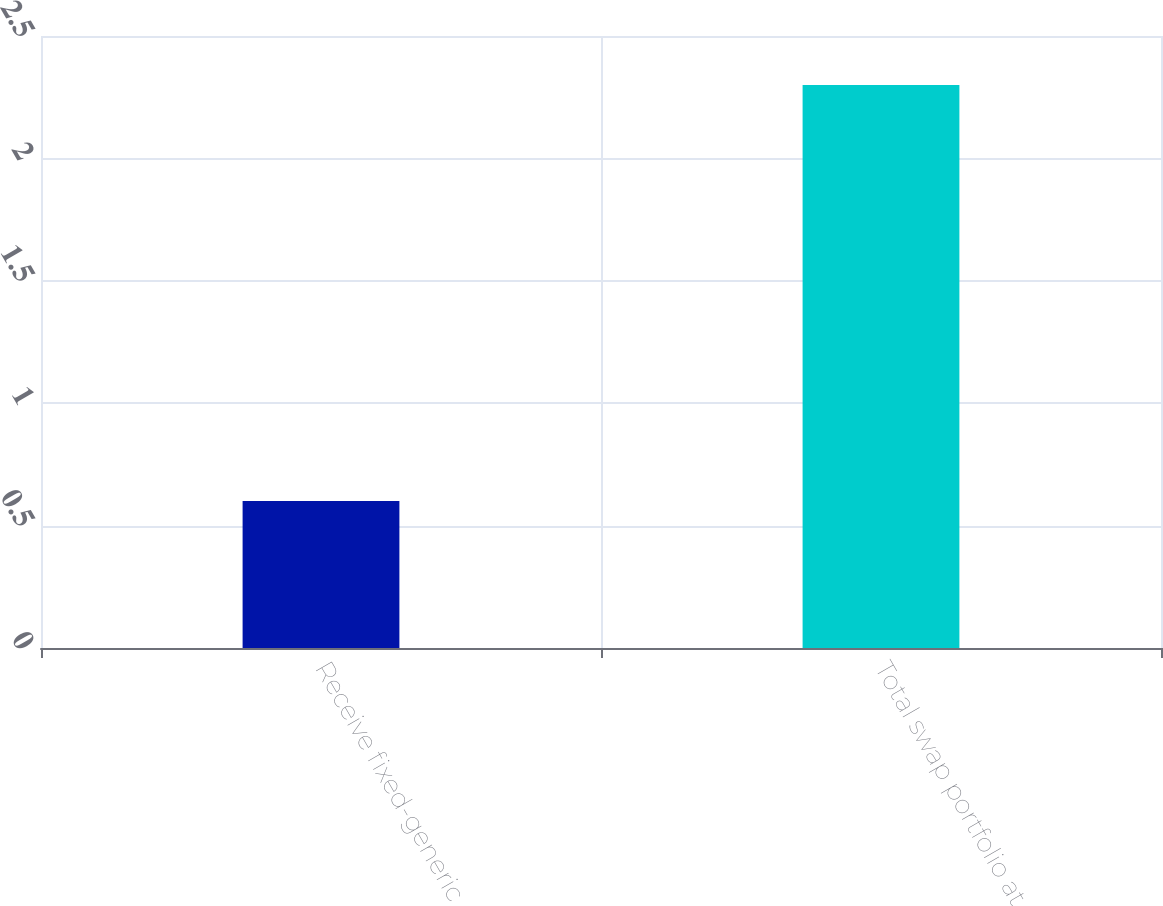Convert chart to OTSL. <chart><loc_0><loc_0><loc_500><loc_500><bar_chart><fcel>Receive fixed-generic<fcel>Total swap portfolio at<nl><fcel>0.6<fcel>2.3<nl></chart> 